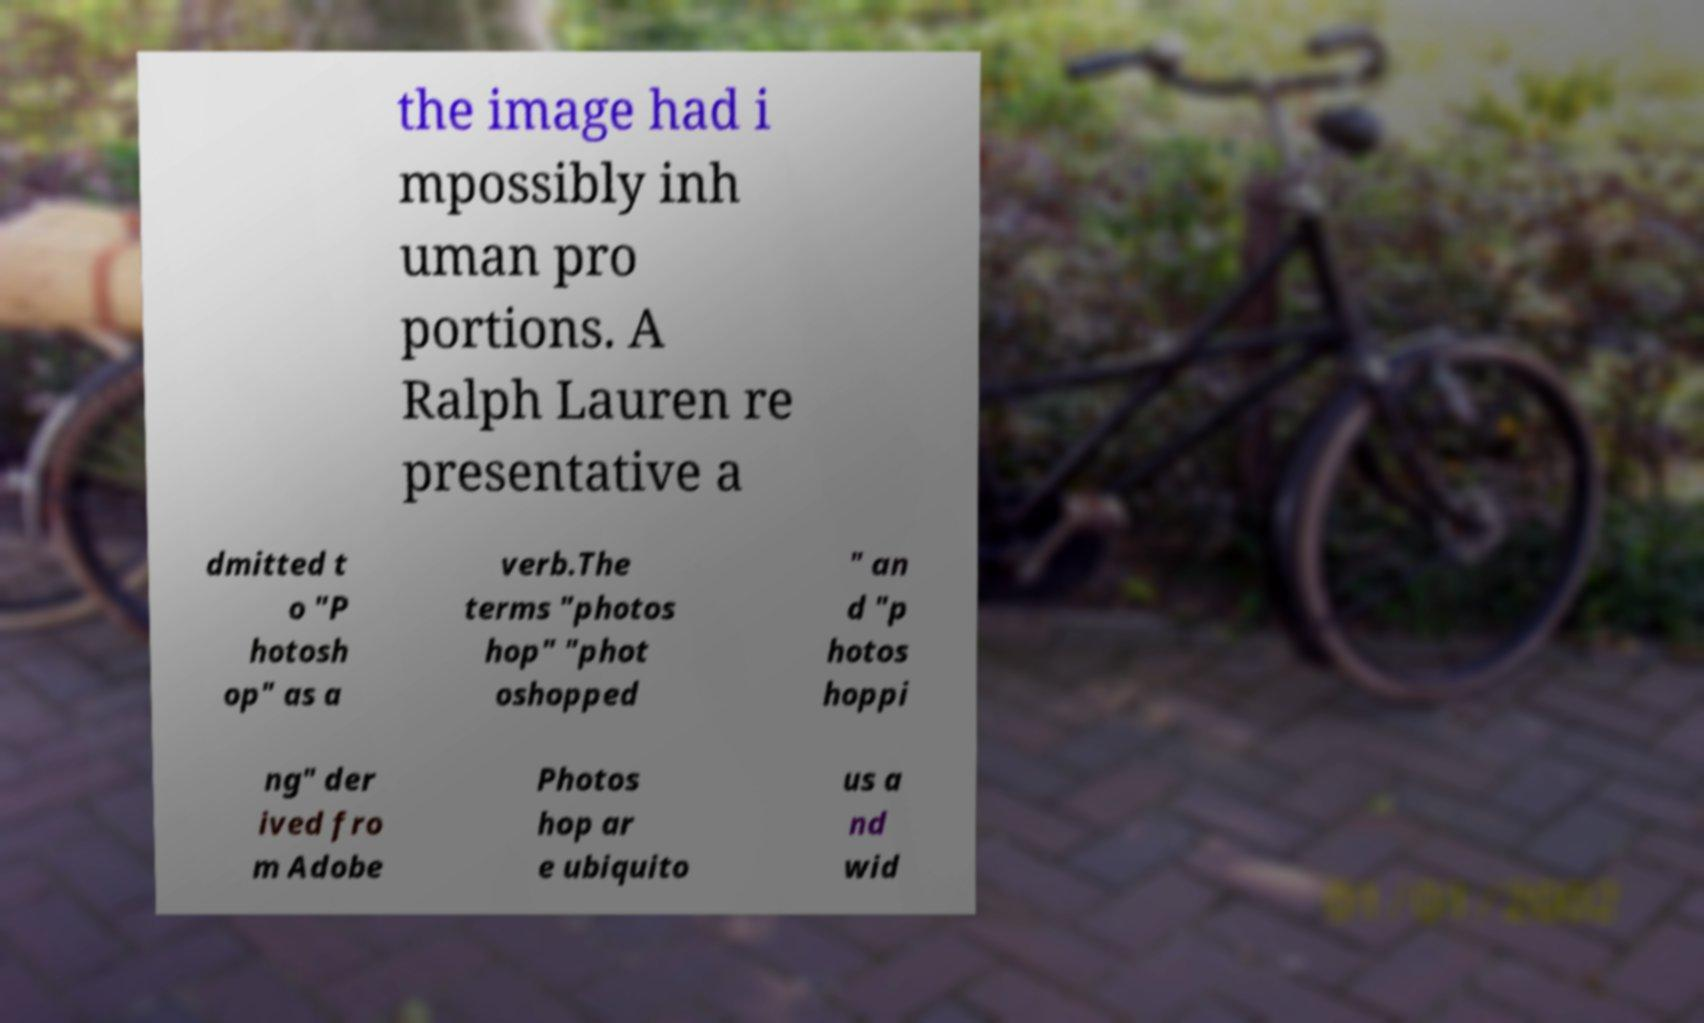I need the written content from this picture converted into text. Can you do that? the image had i mpossibly inh uman pro portions. A Ralph Lauren re presentative a dmitted t o "P hotosh op" as a verb.The terms "photos hop" "phot oshopped " an d "p hotos hoppi ng" der ived fro m Adobe Photos hop ar e ubiquito us a nd wid 